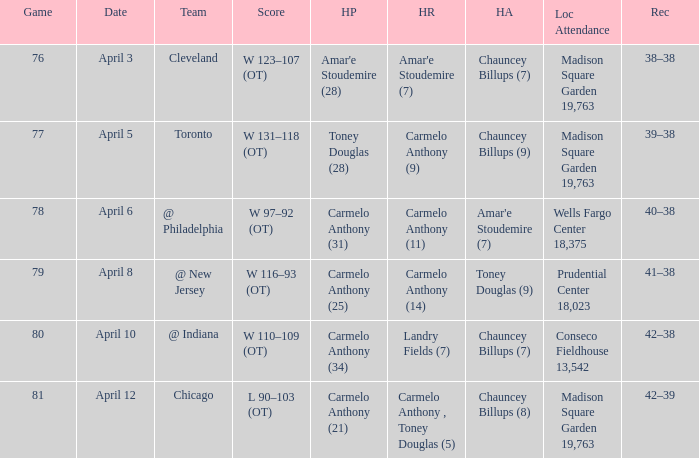Name the location attendance april 5 Madison Square Garden 19,763. 